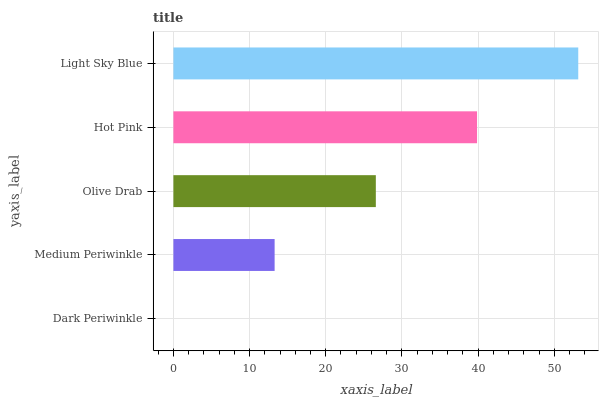Is Dark Periwinkle the minimum?
Answer yes or no. Yes. Is Light Sky Blue the maximum?
Answer yes or no. Yes. Is Medium Periwinkle the minimum?
Answer yes or no. No. Is Medium Periwinkle the maximum?
Answer yes or no. No. Is Medium Periwinkle greater than Dark Periwinkle?
Answer yes or no. Yes. Is Dark Periwinkle less than Medium Periwinkle?
Answer yes or no. Yes. Is Dark Periwinkle greater than Medium Periwinkle?
Answer yes or no. No. Is Medium Periwinkle less than Dark Periwinkle?
Answer yes or no. No. Is Olive Drab the high median?
Answer yes or no. Yes. Is Olive Drab the low median?
Answer yes or no. Yes. Is Medium Periwinkle the high median?
Answer yes or no. No. Is Medium Periwinkle the low median?
Answer yes or no. No. 